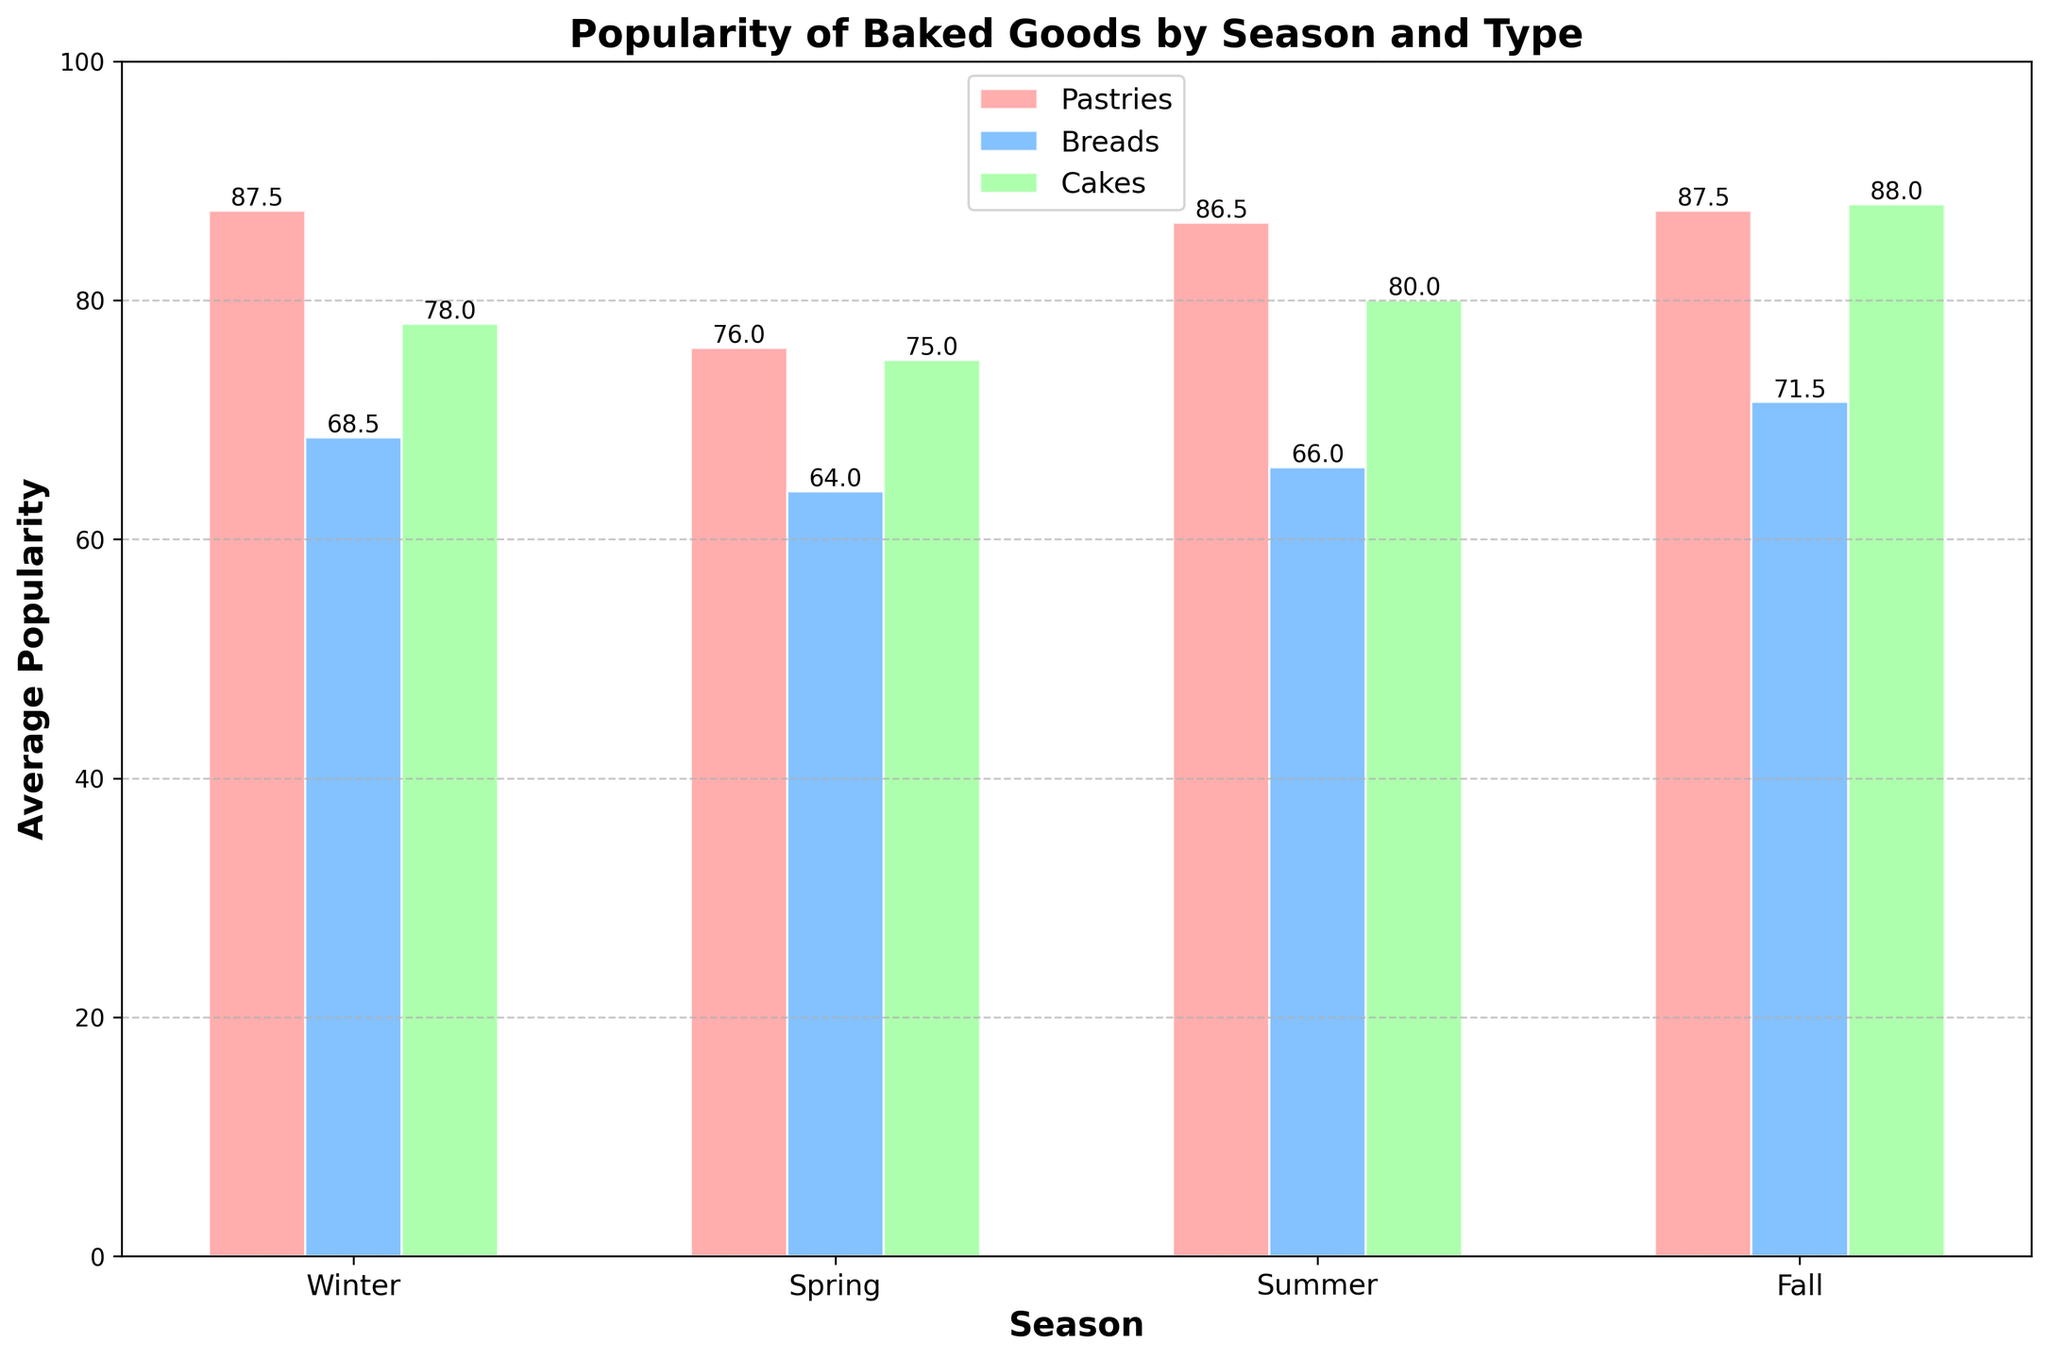What's the most popular type of baked good in Winter? To determine this, look for the highest bar in the Winter season. Croissants, a pastry, have the highest average popularity with a score of 90.
Answer: Pastries Between Winter and Summer, which season has a higher average popularity for breads? Compare the heights of the bars representing breads in both Winter and Summer. In Winter, the average popularity for breads is (72 + 65)/2 = 68.5, while in Summer it is (70 + 62)/2 = 66.
Answer: Winter Which item has the highest average popularity across all types in Fall? Identify the highest bar in the Fall season. The highest bar in Fall is Pumpkin Spice Scones, a pastry, with an average popularity of 92.
Answer: Pumpkin Spice Scones How does the popularity of pastries in Spring compare with Winter? Compare the heights of the bars representing pastries in Spring (Lemon Tarts and Blueberry Muffins) and Winter (Cinnamon Rolls and Croissants). In Winter, the average popularity is (85 + 90)/2 = 87.5 and in Spring, it is (70 + 82)/2 = 76.
Answer: Winter > Spring What is the average popularity of cakes across all seasons? Calculate the mean of the bars labeled as cakes. Winter (78), Spring (75), Summer (80), Fall (88). Average is (78 + 75 + 80 + 88)/4 = 80.25.
Answer: 80.25 Which type of baked good is least popular in Spring? Identify the shortest bar in Spring. The shortest bar is for Focaccia, a bread, with an average popularity of 60.
Answer: Breads Which season has the most consistent popularity across all types? Consistency can be checked by observing bars of similar heights. Winter has bars of popularity 85, 90, 72, 65, and 78, which are closer to each other compared to other seasons.
Answer: Winter Are cakes more popular in Summer or Fall? Compare the heights of the cakes bars in Summer and Fall. The bar for cakes in Summer is Strawberry Shortcake (80) and in Fall is Apple Pie (88).
Answer: Fall What is the popularity difference between the most popular and least popular type of baked good in Summer? Determine the highest and lowest bars in Summer. The highest bar is Fruit Danish (88) and the lowest is Ciabatta (62). Difference is 88 - 62 = 26.
Answer: 26 Are any breads more popular than the most popular pastry in Spring? Identify the most popular pastry in Spring, which is Blueberry Muffins (82). Compare with breads in Spring, which are Banana Bread (68) and Focaccia (60). Neither bread popularity exceeds 82.
Answer: No 